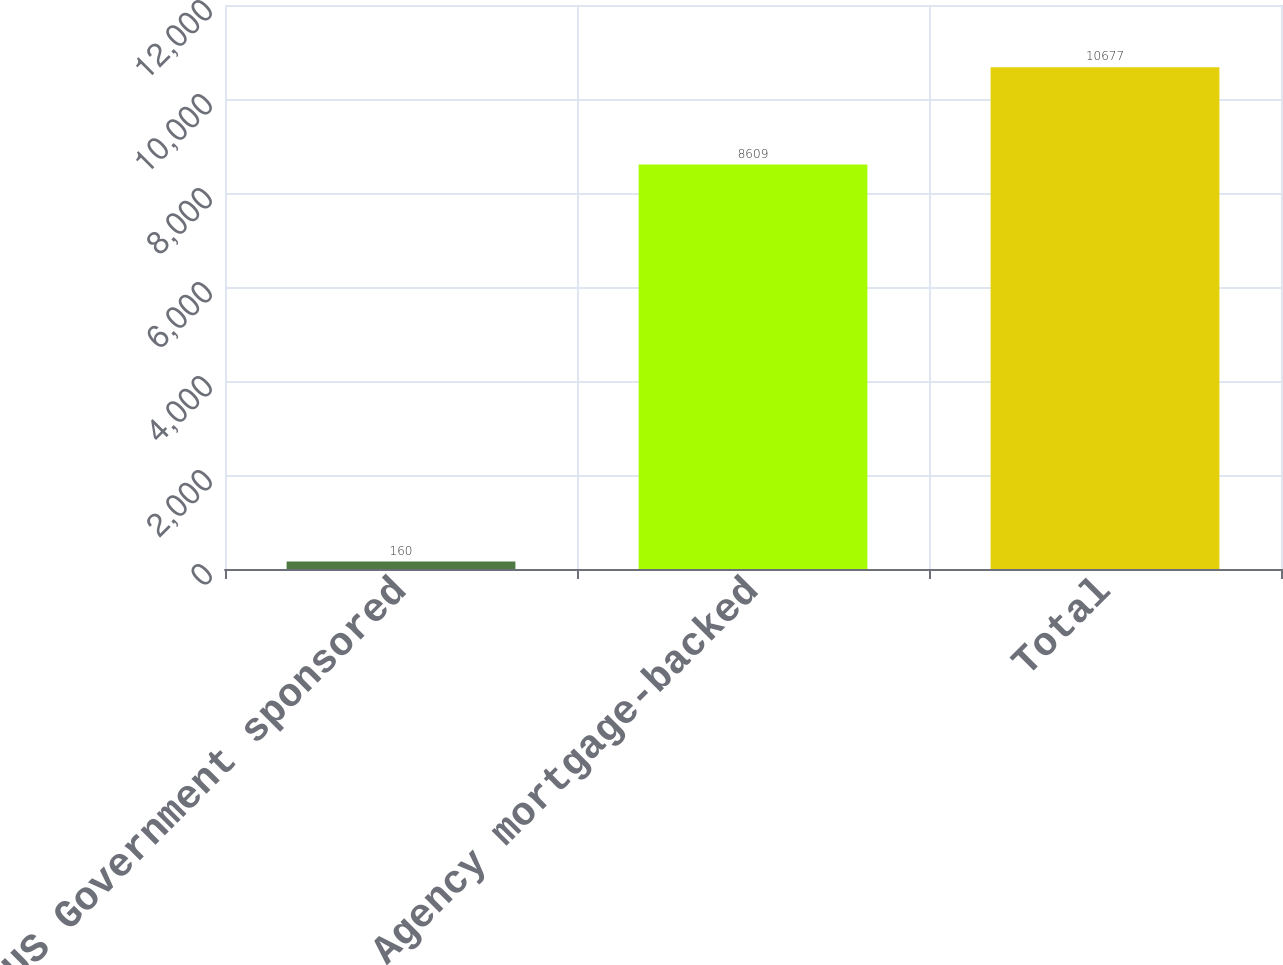<chart> <loc_0><loc_0><loc_500><loc_500><bar_chart><fcel>US Government sponsored<fcel>Agency mortgage-backed<fcel>Total<nl><fcel>160<fcel>8609<fcel>10677<nl></chart> 